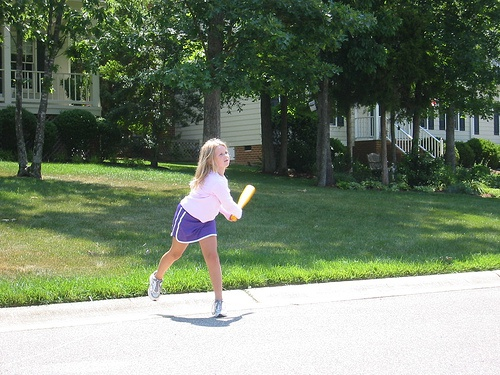Describe the objects in this image and their specific colors. I can see people in black, lavender, purple, darkgray, and tan tones, baseball bat in black, ivory, khaki, and orange tones, and chair in black and gray tones in this image. 